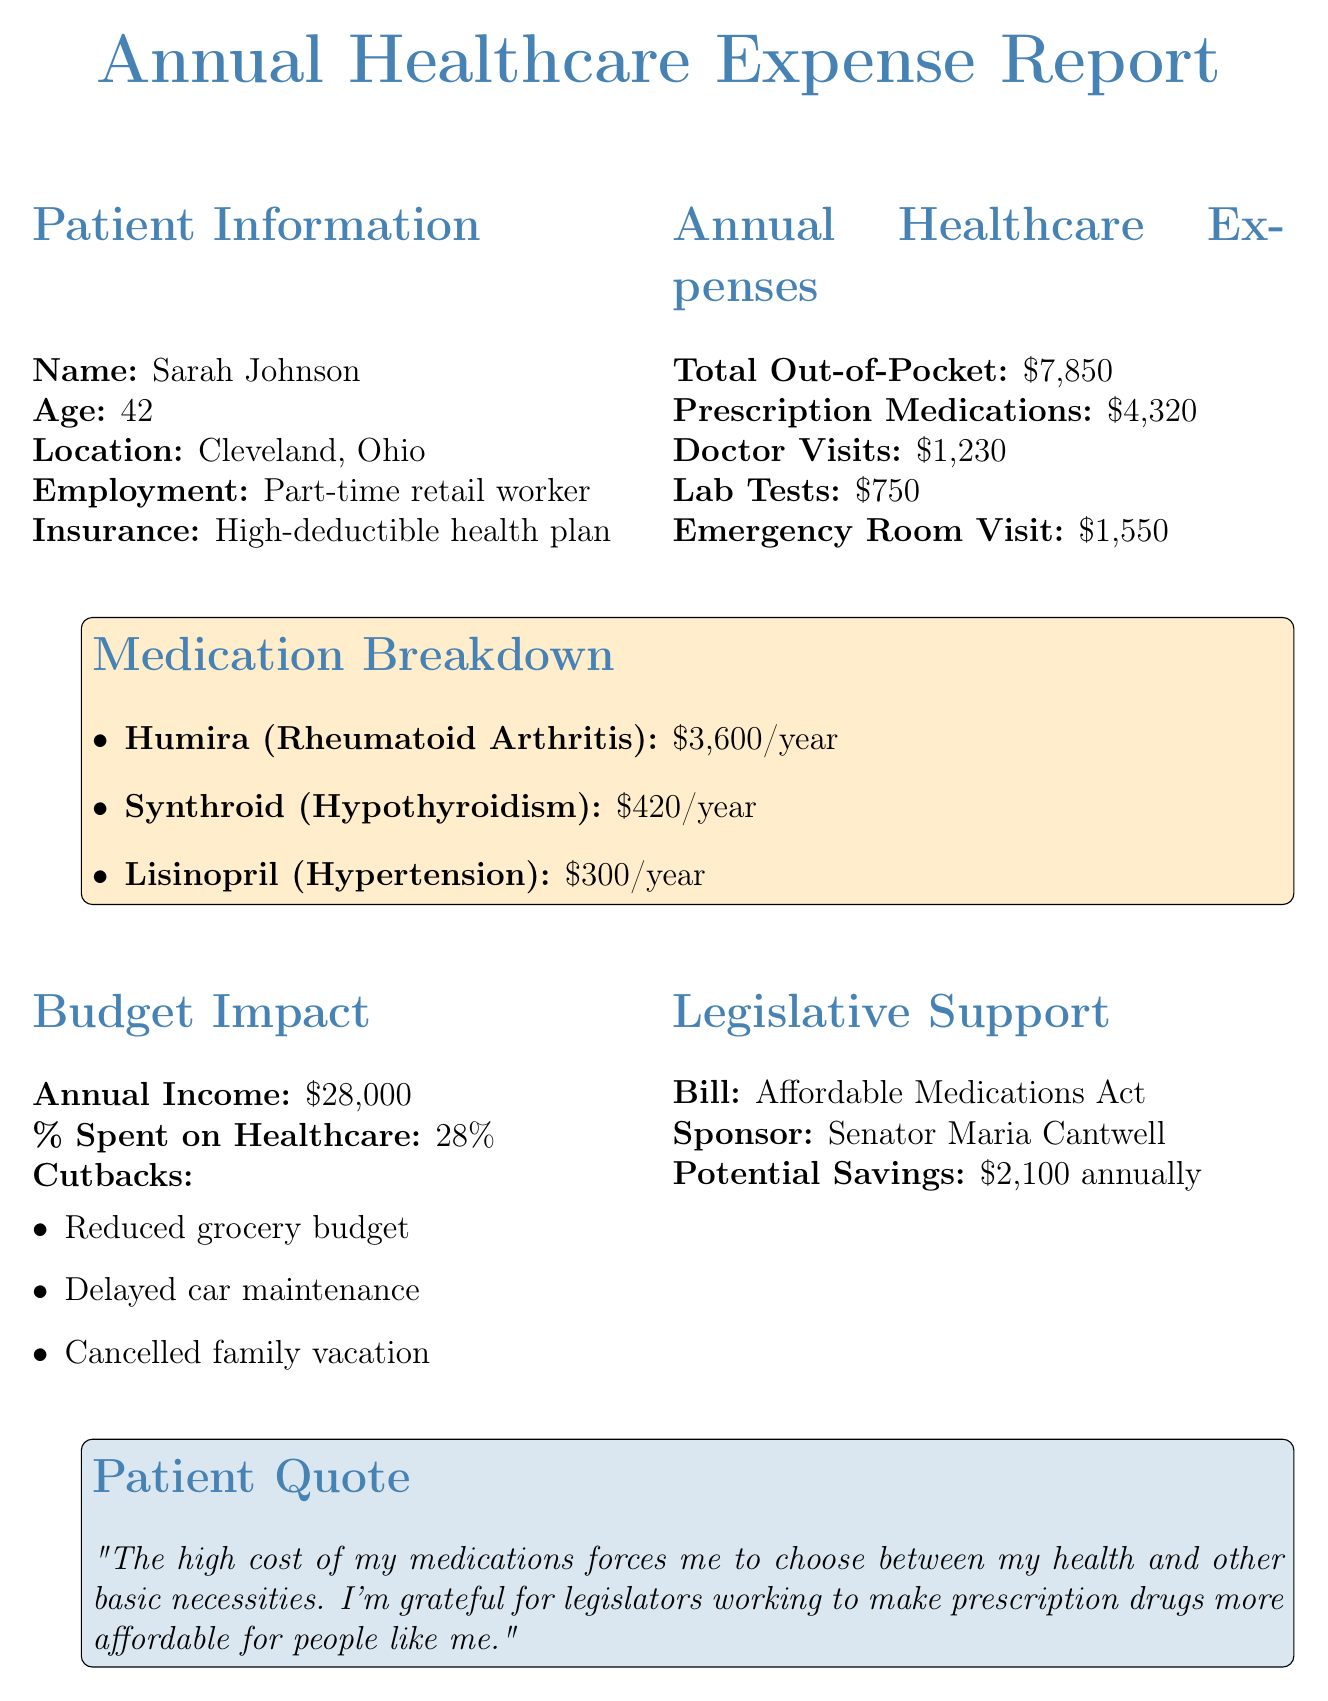What is the total out-of-pocket healthcare expense? The total out-of-pocket healthcare expense is listed as $7,850 in the report.
Answer: $7,850 How much is spent on prescription medications? The report shows that prescription medications cost $4,320 annually.
Answer: $4,320 Who sponsors the Affordable Medications Act? The sponsoring legislator for the Affordable Medications Act is Senator Maria Cantwell.
Answer: Senator Maria Cantwell What percentage of Sarah's income is spent on healthcare? The document indicates that 28% of Sarah's annual income is spent on healthcare expenses.
Answer: 28% What is the annual cost of Humira? The cost of Humira for treating Rheumatoid Arthritis is $3,600 per year according to the document.
Answer: $3,600 What cutback did Sarah not make due to medication costs? Sarah cancelled her family vacation as a cutback due to high medication costs.
Answer: Cancelled family vacation What is Sarah's annual income? The report specifies Sarah's annual income as $28,000.
Answer: $28,000 What is the potential savings from the Affordable Medications Act? The potential savings indicated by the report is $2,100 annually.
Answer: $2,100 Why does Sarah appreciate the efforts of legislators? Sarah appreciates legislators’ efforts because they work to make prescription drugs more affordable for people like her.
Answer: Affordable medications 